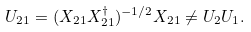<formula> <loc_0><loc_0><loc_500><loc_500>U _ { 2 1 } = ( X _ { 2 1 } X _ { 2 1 } ^ { \dagger } ) ^ { - 1 / 2 } X _ { 2 1 } \ne U _ { 2 } U _ { 1 } .</formula> 